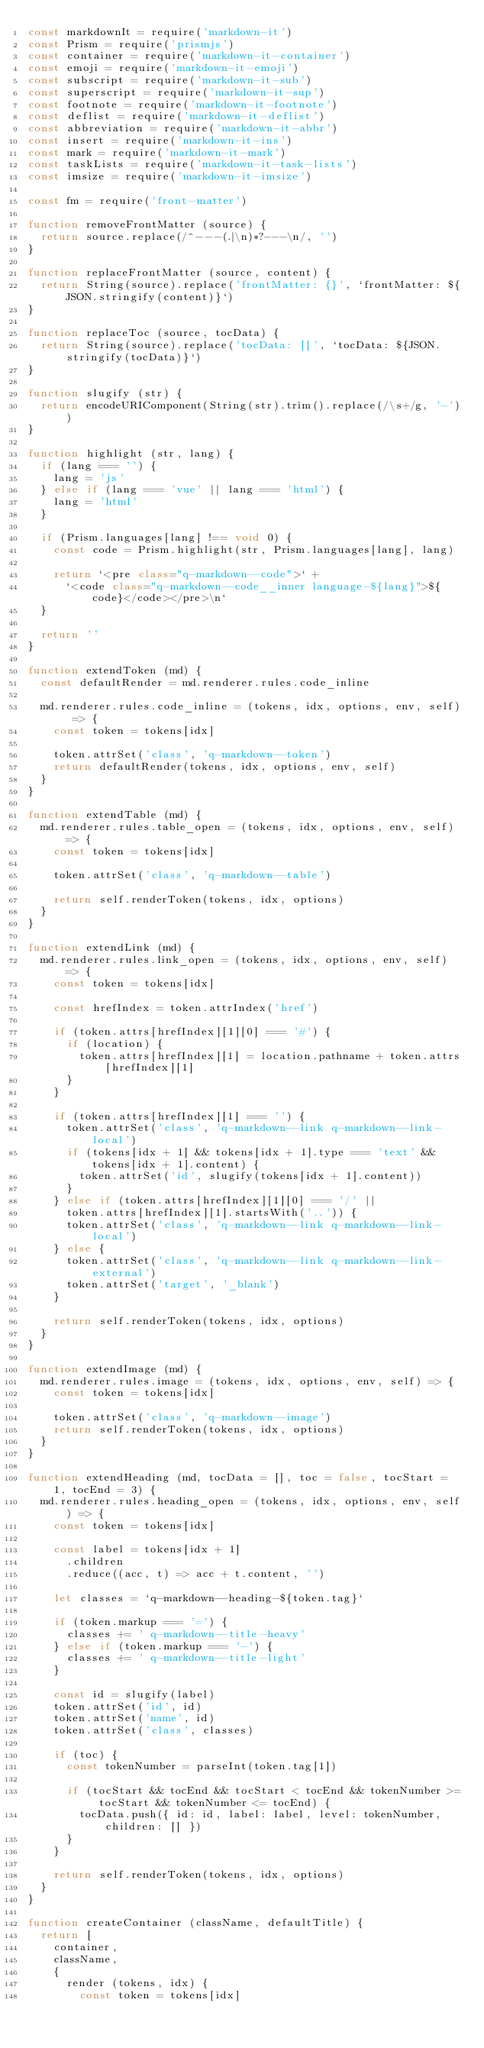<code> <loc_0><loc_0><loc_500><loc_500><_JavaScript_>const markdownIt = require('markdown-it')
const Prism = require('prismjs')
const container = require('markdown-it-container')
const emoji = require('markdown-it-emoji')
const subscript = require('markdown-it-sub')
const superscript = require('markdown-it-sup')
const footnote = require('markdown-it-footnote')
const deflist = require('markdown-it-deflist')
const abbreviation = require('markdown-it-abbr')
const insert = require('markdown-it-ins')
const mark = require('markdown-it-mark')
const taskLists = require('markdown-it-task-lists')
const imsize = require('markdown-it-imsize')

const fm = require('front-matter')

function removeFrontMatter (source) {
  return source.replace(/^---(.|\n)*?---\n/, '')
}

function replaceFrontMatter (source, content) {
  return String(source).replace('frontMatter: {}', `frontMatter: ${JSON.stringify(content)}`)
}

function replaceToc (source, tocData) {
  return String(source).replace('tocData: []', `tocData: ${JSON.stringify(tocData)}`)
}

function slugify (str) {
  return encodeURIComponent(String(str).trim().replace(/\s+/g, '-'))
}

function highlight (str, lang) {
  if (lang === '') {
    lang = 'js'
  } else if (lang === 'vue' || lang === 'html') {
    lang = 'html'
  }

  if (Prism.languages[lang] !== void 0) {
    const code = Prism.highlight(str, Prism.languages[lang], lang)

    return `<pre class="q-markdown--code">` +
      `<code class="q-markdown--code__inner language-${lang}">${code}</code></pre>\n`
  }

  return ''
}

function extendToken (md) {
  const defaultRender = md.renderer.rules.code_inline

  md.renderer.rules.code_inline = (tokens, idx, options, env, self) => {
    const token = tokens[idx]

    token.attrSet('class', 'q-markdown--token')
    return defaultRender(tokens, idx, options, env, self)
  }
}

function extendTable (md) {
  md.renderer.rules.table_open = (tokens, idx, options, env, self) => {
    const token = tokens[idx]

    token.attrSet('class', 'q-markdown--table')

    return self.renderToken(tokens, idx, options)
  }
}

function extendLink (md) {
  md.renderer.rules.link_open = (tokens, idx, options, env, self) => {
    const token = tokens[idx]

    const hrefIndex = token.attrIndex('href')

    if (token.attrs[hrefIndex][1][0] === '#') {
      if (location) {
        token.attrs[hrefIndex][1] = location.pathname + token.attrs[hrefIndex][1]
      }
    }

    if (token.attrs[hrefIndex][1] === '') {
      token.attrSet('class', 'q-markdown--link q-markdown--link-local')
      if (tokens[idx + 1] && tokens[idx + 1].type === 'text' && tokens[idx + 1].content) {
        token.attrSet('id', slugify(tokens[idx + 1].content))
      }
    } else if (token.attrs[hrefIndex][1][0] === '/' ||
      token.attrs[hrefIndex][1].startsWith('..')) {
      token.attrSet('class', 'q-markdown--link q-markdown--link-local')
    } else {
      token.attrSet('class', 'q-markdown--link q-markdown--link-external')
      token.attrSet('target', '_blank')
    }

    return self.renderToken(tokens, idx, options)
  }
}

function extendImage (md) {
  md.renderer.rules.image = (tokens, idx, options, env, self) => {
    const token = tokens[idx]

    token.attrSet('class', 'q-markdown--image')
    return self.renderToken(tokens, idx, options)
  }
}

function extendHeading (md, tocData = [], toc = false, tocStart = 1, tocEnd = 3) {
  md.renderer.rules.heading_open = (tokens, idx, options, env, self) => {
    const token = tokens[idx]

    const label = tokens[idx + 1]
      .children
      .reduce((acc, t) => acc + t.content, '')

    let classes = `q-markdown--heading-${token.tag}`

    if (token.markup === '=') {
      classes += ' q-markdown--title-heavy'
    } else if (token.markup === '-') {
      classes += ' q-markdown--title-light'
    }

    const id = slugify(label)
    token.attrSet('id', id)
    token.attrSet('name', id)
    token.attrSet('class', classes)

    if (toc) {
      const tokenNumber = parseInt(token.tag[1])

      if (tocStart && tocEnd && tocStart < tocEnd && tokenNumber >= tocStart && tokenNumber <= tocEnd) {
        tocData.push({ id: id, label: label, level: tokenNumber, children: [] })
      }
    }

    return self.renderToken(tokens, idx, options)
  }
}

function createContainer (className, defaultTitle) {
  return [
    container,
    className,
    {
      render (tokens, idx) {
        const token = tokens[idx]</code> 